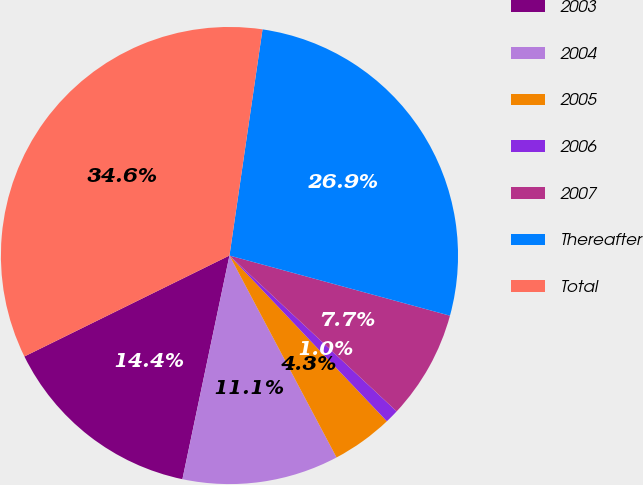Convert chart. <chart><loc_0><loc_0><loc_500><loc_500><pie_chart><fcel>2003<fcel>2004<fcel>2005<fcel>2006<fcel>2007<fcel>Thereafter<fcel>Total<nl><fcel>14.42%<fcel>11.06%<fcel>4.33%<fcel>0.97%<fcel>7.7%<fcel>26.93%<fcel>34.59%<nl></chart> 